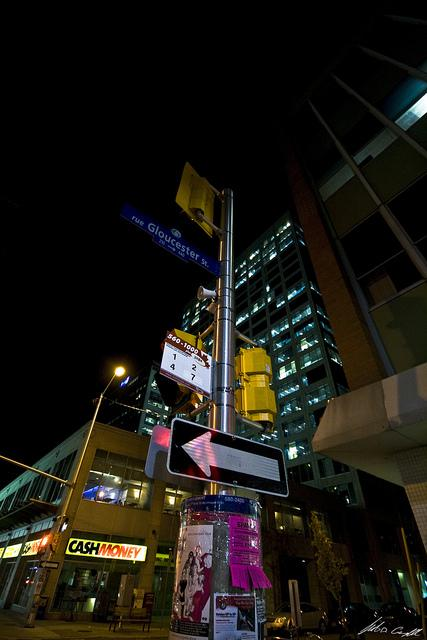What does the white arrow sign usually mean? one way 